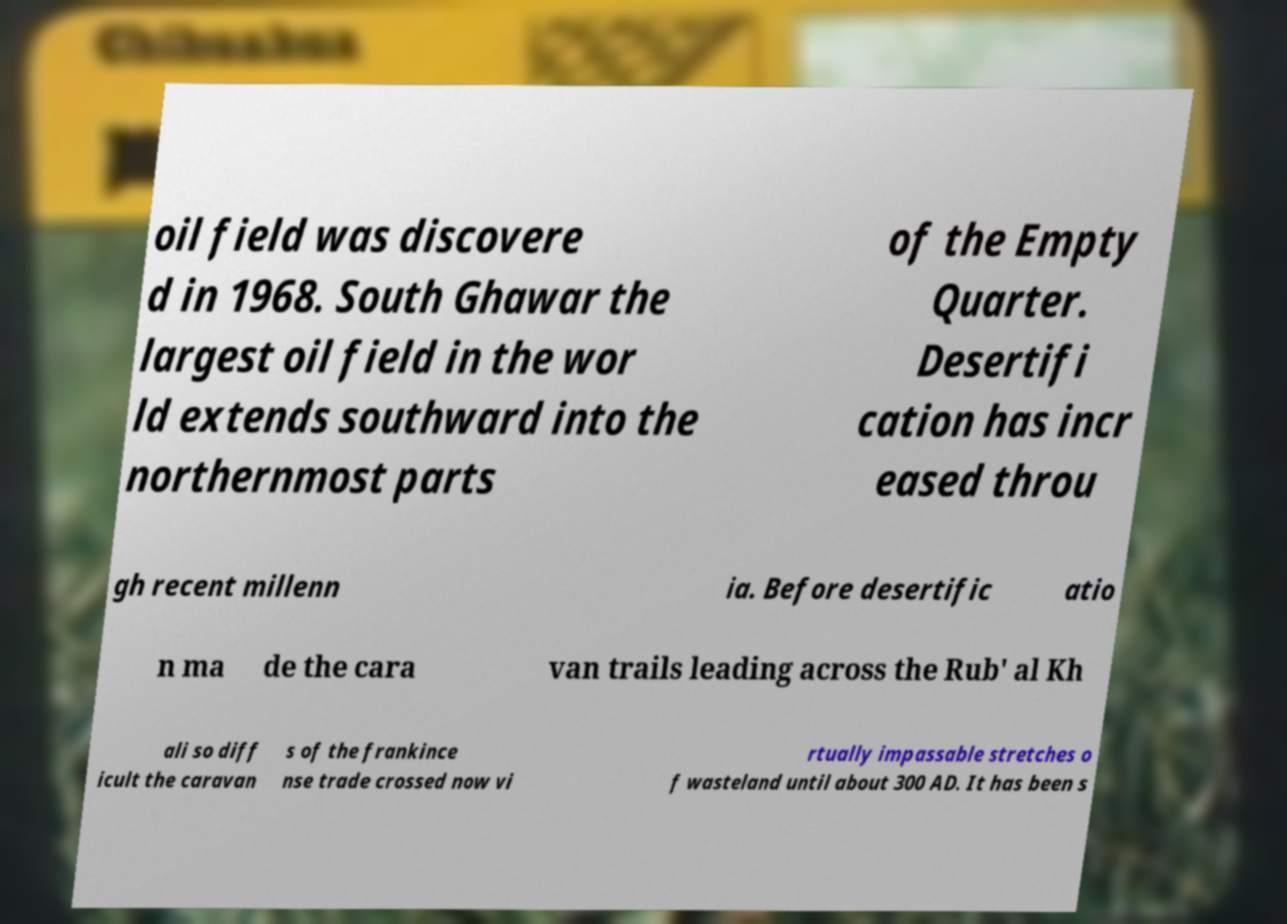Please identify and transcribe the text found in this image. oil field was discovere d in 1968. South Ghawar the largest oil field in the wor ld extends southward into the northernmost parts of the Empty Quarter. Desertifi cation has incr eased throu gh recent millenn ia. Before desertific atio n ma de the cara van trails leading across the Rub' al Kh ali so diff icult the caravan s of the frankince nse trade crossed now vi rtually impassable stretches o f wasteland until about 300 AD. It has been s 